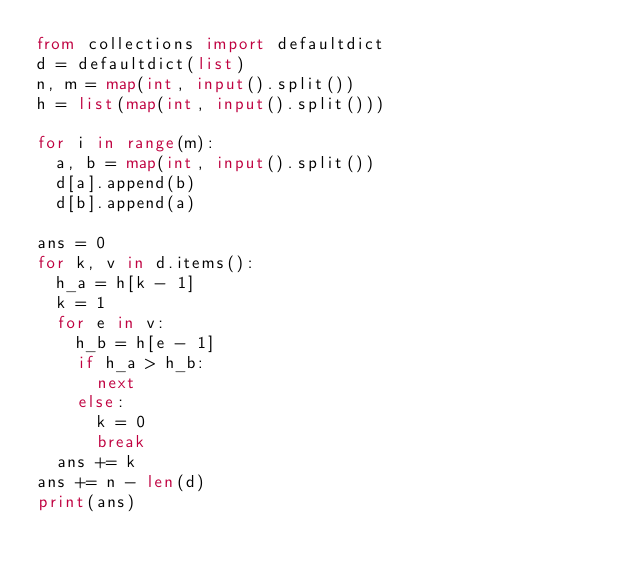<code> <loc_0><loc_0><loc_500><loc_500><_Python_>from collections import defaultdict
d = defaultdict(list)
n, m = map(int, input().split())
h = list(map(int, input().split()))

for i in range(m):
  a, b = map(int, input().split())
  d[a].append(b)
  d[b].append(a)

ans = 0
for k, v in d.items():
  h_a = h[k - 1]
  k = 1
  for e in v:
    h_b = h[e - 1]
    if h_a > h_b:
      next
    else:
      k = 0
      break
  ans += k
ans += n - len(d)
print(ans)</code> 